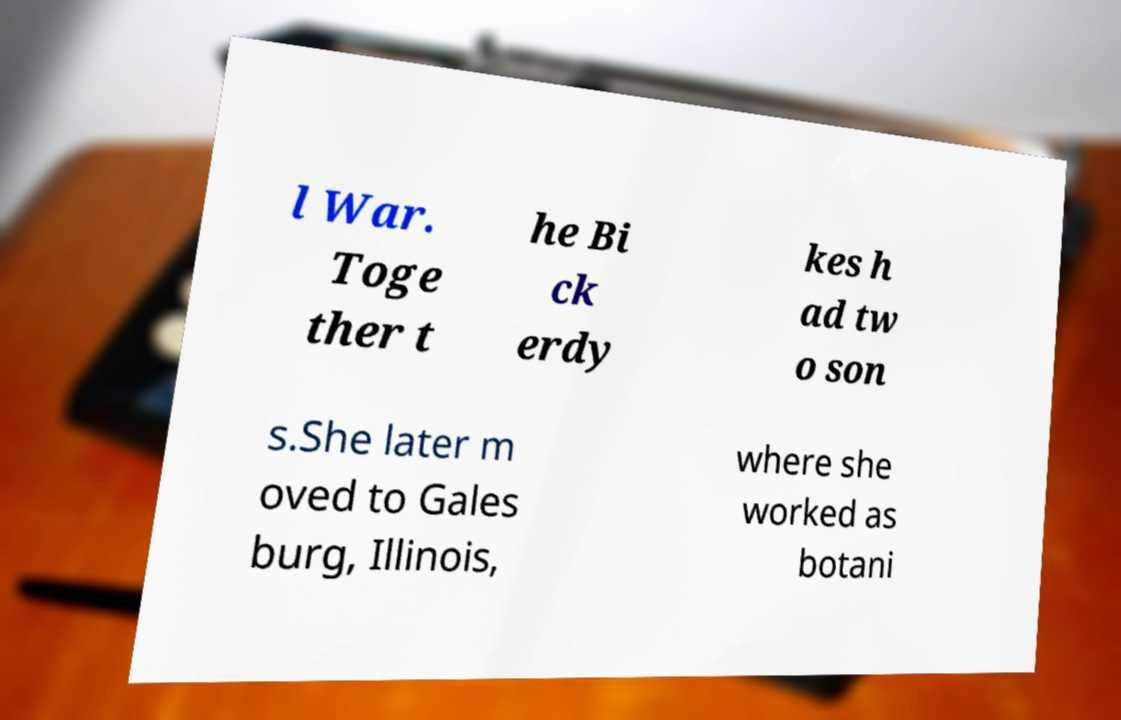I need the written content from this picture converted into text. Can you do that? l War. Toge ther t he Bi ck erdy kes h ad tw o son s.She later m oved to Gales burg, Illinois, where she worked as botani 